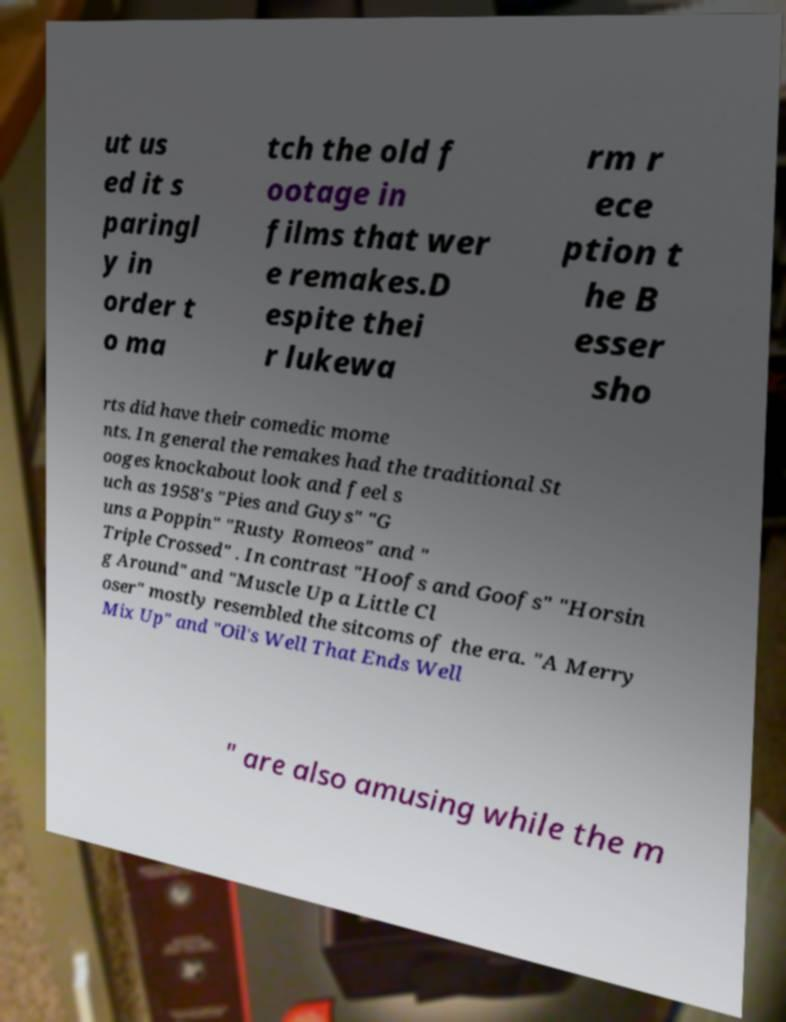What messages or text are displayed in this image? I need them in a readable, typed format. ut us ed it s paringl y in order t o ma tch the old f ootage in films that wer e remakes.D espite thei r lukewa rm r ece ption t he B esser sho rts did have their comedic mome nts. In general the remakes had the traditional St ooges knockabout look and feel s uch as 1958's "Pies and Guys" "G uns a Poppin" "Rusty Romeos" and " Triple Crossed" . In contrast "Hoofs and Goofs" "Horsin g Around" and "Muscle Up a Little Cl oser" mostly resembled the sitcoms of the era. "A Merry Mix Up" and "Oil's Well That Ends Well " are also amusing while the m 